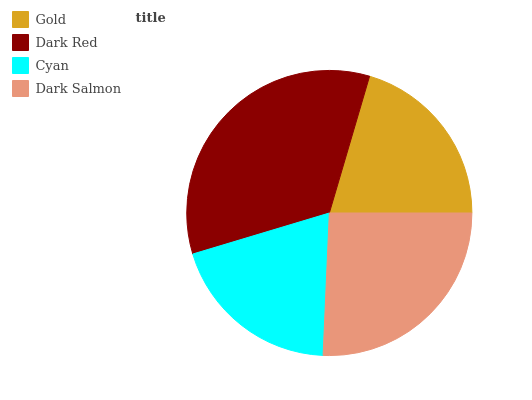Is Cyan the minimum?
Answer yes or no. Yes. Is Dark Red the maximum?
Answer yes or no. Yes. Is Dark Red the minimum?
Answer yes or no. No. Is Cyan the maximum?
Answer yes or no. No. Is Dark Red greater than Cyan?
Answer yes or no. Yes. Is Cyan less than Dark Red?
Answer yes or no. Yes. Is Cyan greater than Dark Red?
Answer yes or no. No. Is Dark Red less than Cyan?
Answer yes or no. No. Is Dark Salmon the high median?
Answer yes or no. Yes. Is Gold the low median?
Answer yes or no. Yes. Is Dark Red the high median?
Answer yes or no. No. Is Cyan the low median?
Answer yes or no. No. 